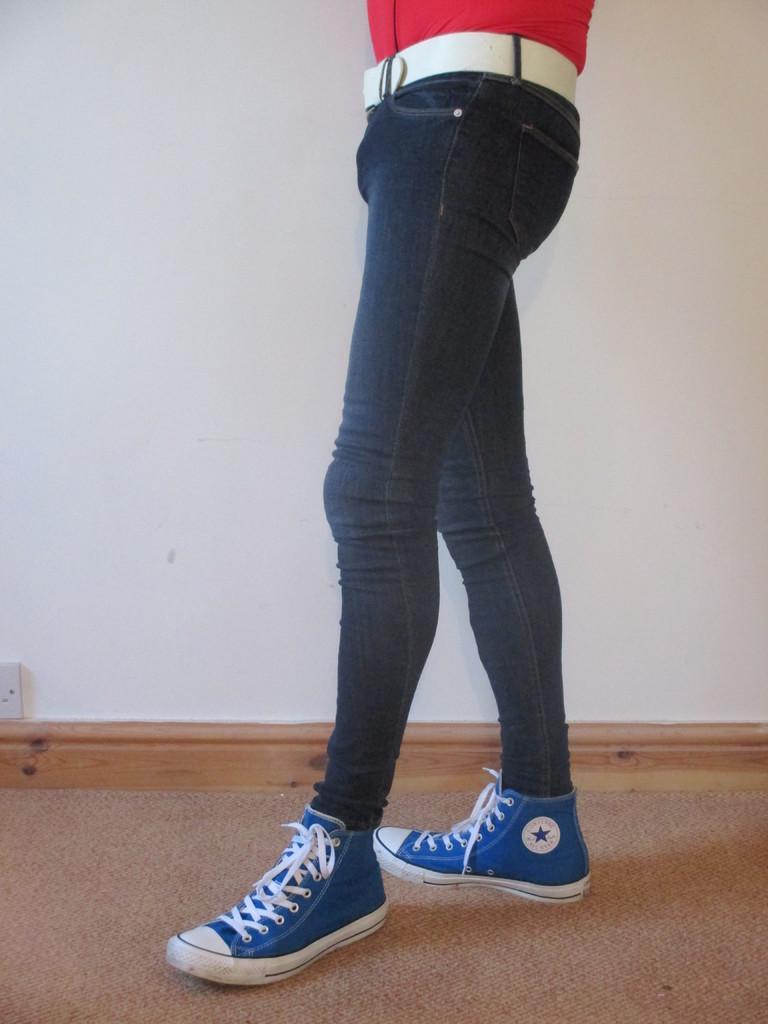Please provide a concise description of this image. In the image only the half part of the person is visible, the person is wearing jeans and blue shoes. Behind the person there is a wall. 